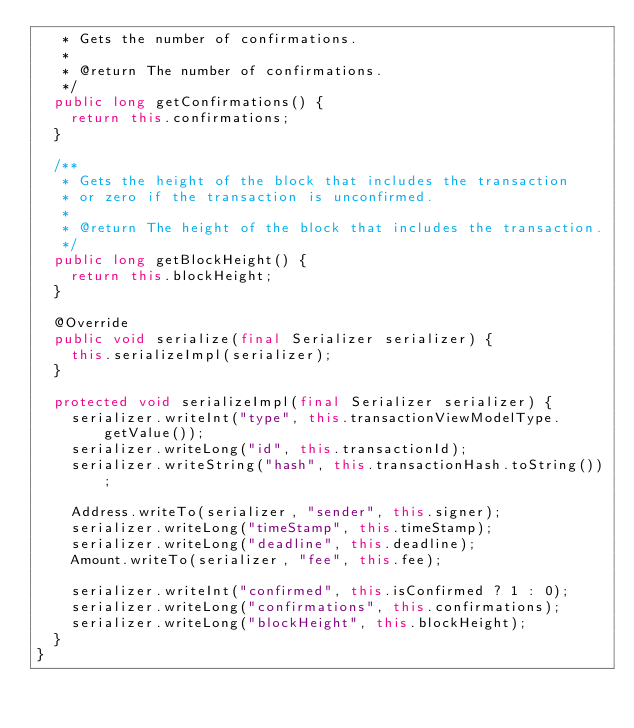<code> <loc_0><loc_0><loc_500><loc_500><_Java_>	 * Gets the number of confirmations.
	 *
	 * @return The number of confirmations.
	 */
	public long getConfirmations() {
		return this.confirmations;
	}

	/**
	 * Gets the height of the block that includes the transaction
	 * or zero if the transaction is unconfirmed.
	 *
	 * @return The height of the block that includes the transaction.
	 */
	public long getBlockHeight() {
		return this.blockHeight;
	}

	@Override
	public void serialize(final Serializer serializer) {
		this.serializeImpl(serializer);
	}

	protected void serializeImpl(final Serializer serializer) {
		serializer.writeInt("type", this.transactionViewModelType.getValue());
		serializer.writeLong("id", this.transactionId);
		serializer.writeString("hash", this.transactionHash.toString());

		Address.writeTo(serializer, "sender", this.signer);
		serializer.writeLong("timeStamp", this.timeStamp);
		serializer.writeLong("deadline", this.deadline);
		Amount.writeTo(serializer, "fee", this.fee);

		serializer.writeInt("confirmed", this.isConfirmed ? 1 : 0);
		serializer.writeLong("confirmations", this.confirmations);
		serializer.writeLong("blockHeight", this.blockHeight);
	}
}
</code> 